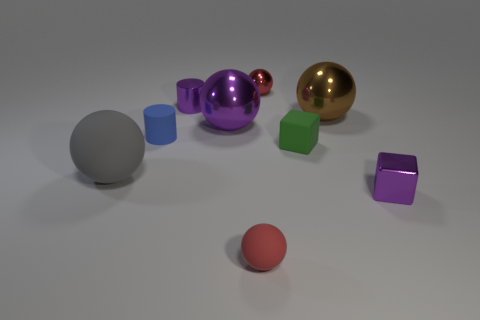What is the texture of the surface that the objects are resting on? The surface appears to be smooth with a slightly matte finish, creating soft shadows under the objects. Do the shadows tell us anything about the light source? Yes, the shadows are soft and indicate that the light source is diffused, possibly coming from a wide-angle overhead light. 